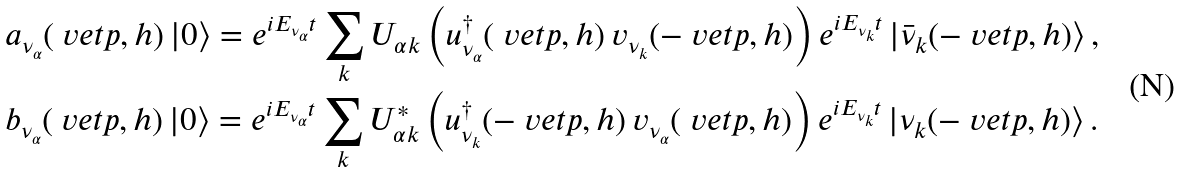<formula> <loc_0><loc_0><loc_500><loc_500>\null & \null a _ { \nu _ { \alpha } } ( \ v e t { p } , h ) \, | 0 \rangle = e ^ { i E _ { \nu _ { \alpha } } t } \sum _ { k } U _ { \alpha k } \left ( u _ { \nu _ { \alpha } } ^ { \dagger } ( \ v e t { p } , h ) \, v _ { \nu _ { k } } ( - \ v e t { p } , h ) \right ) e ^ { i E _ { \nu _ { k } } t } \, | \bar { \nu } _ { k } ( - \ v e t { p } , h ) \rangle \, , \\ \null & \null b _ { \nu _ { \alpha } } ( \ v e t { p } , h ) \, | 0 \rangle = e ^ { i E _ { \nu _ { \alpha } } t } \sum _ { k } U _ { \alpha k } ^ { * } \left ( u _ { \nu _ { k } } ^ { \dagger } ( - \ v e t { p } , h ) \, v _ { \nu _ { \alpha } } ( \ v e t { p } , h ) \right ) e ^ { i E _ { \nu _ { k } } t } \, | \nu _ { k } ( - \ v e t { p } , h ) \rangle \, .</formula> 